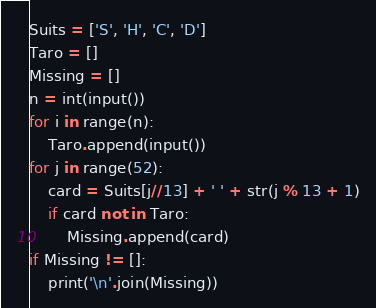<code> <loc_0><loc_0><loc_500><loc_500><_Python_>Suits = ['S', 'H', 'C', 'D']
Taro = []
Missing = []
n = int(input())
for i in range(n):
    Taro.append(input())
for j in range(52):
    card = Suits[j//13] + ' ' + str(j % 13 + 1)
    if card not in Taro:
        Missing.append(card)
if Missing != []:
    print('\n'.join(Missing))</code> 